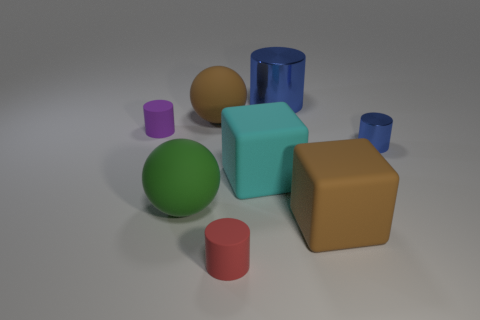Subtract all small blue cylinders. How many cylinders are left? 3 Subtract all gray balls. How many blue cylinders are left? 2 Add 2 tiny shiny cylinders. How many objects exist? 10 Subtract all blue cylinders. How many cylinders are left? 2 Subtract all spheres. How many objects are left? 6 Subtract all matte cubes. Subtract all tiny purple matte objects. How many objects are left? 5 Add 2 blue metal objects. How many blue metal objects are left? 4 Add 7 tiny green metal balls. How many tiny green metal balls exist? 7 Subtract 0 blue spheres. How many objects are left? 8 Subtract all gray cubes. Subtract all gray balls. How many cubes are left? 2 